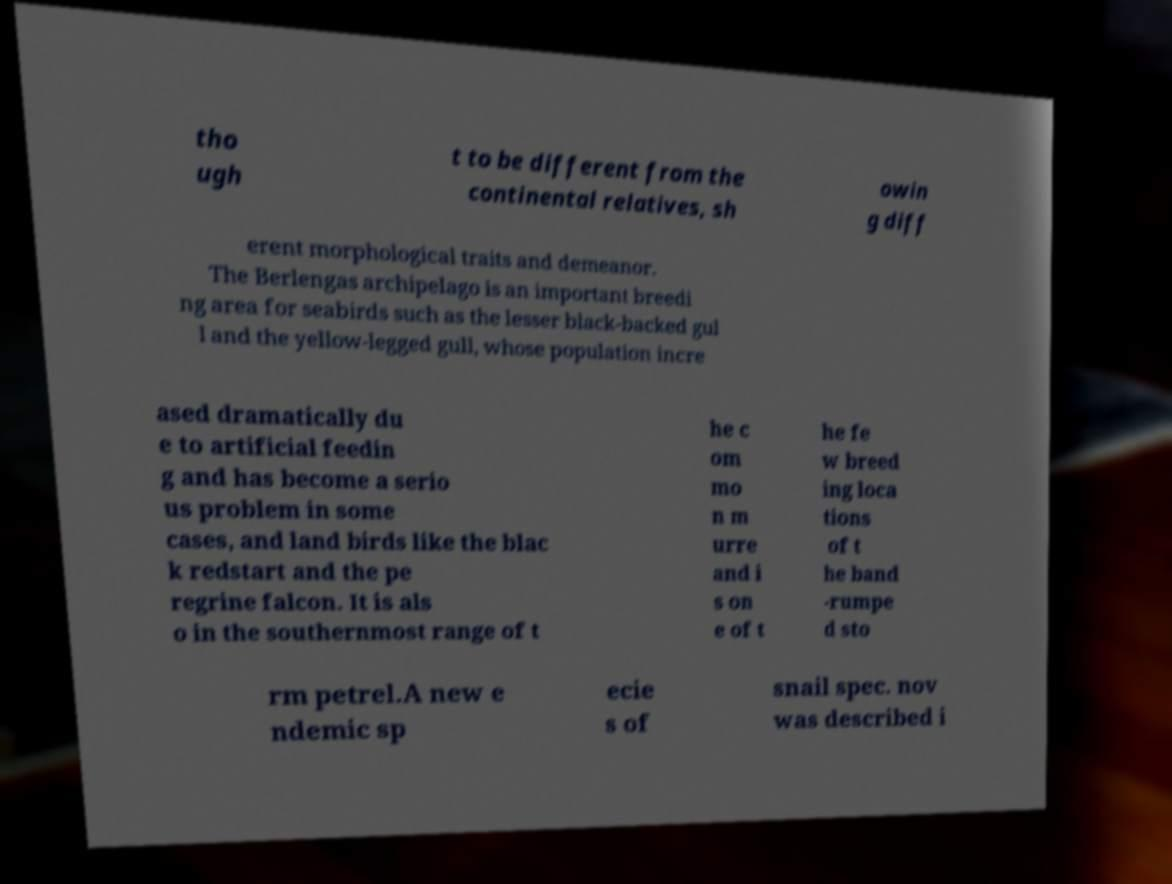Can you accurately transcribe the text from the provided image for me? tho ugh t to be different from the continental relatives, sh owin g diff erent morphological traits and demeanor. The Berlengas archipelago is an important breedi ng area for seabirds such as the lesser black-backed gul l and the yellow-legged gull, whose population incre ased dramatically du e to artificial feedin g and has become a serio us problem in some cases, and land birds like the blac k redstart and the pe regrine falcon. It is als o in the southernmost range of t he c om mo n m urre and i s on e of t he fe w breed ing loca tions of t he band -rumpe d sto rm petrel.A new e ndemic sp ecie s of snail spec. nov was described i 